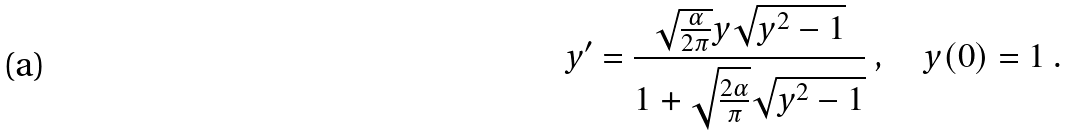<formula> <loc_0><loc_0><loc_500><loc_500>y ^ { \prime } = \frac { \sqrt { \frac { \alpha } { 2 \pi } } y \sqrt { y ^ { 2 } - 1 } } { 1 + \sqrt { \frac { 2 \alpha } { \pi } } \sqrt { y ^ { 2 } - 1 } } \ , \quad y ( 0 ) = 1 \ .</formula> 